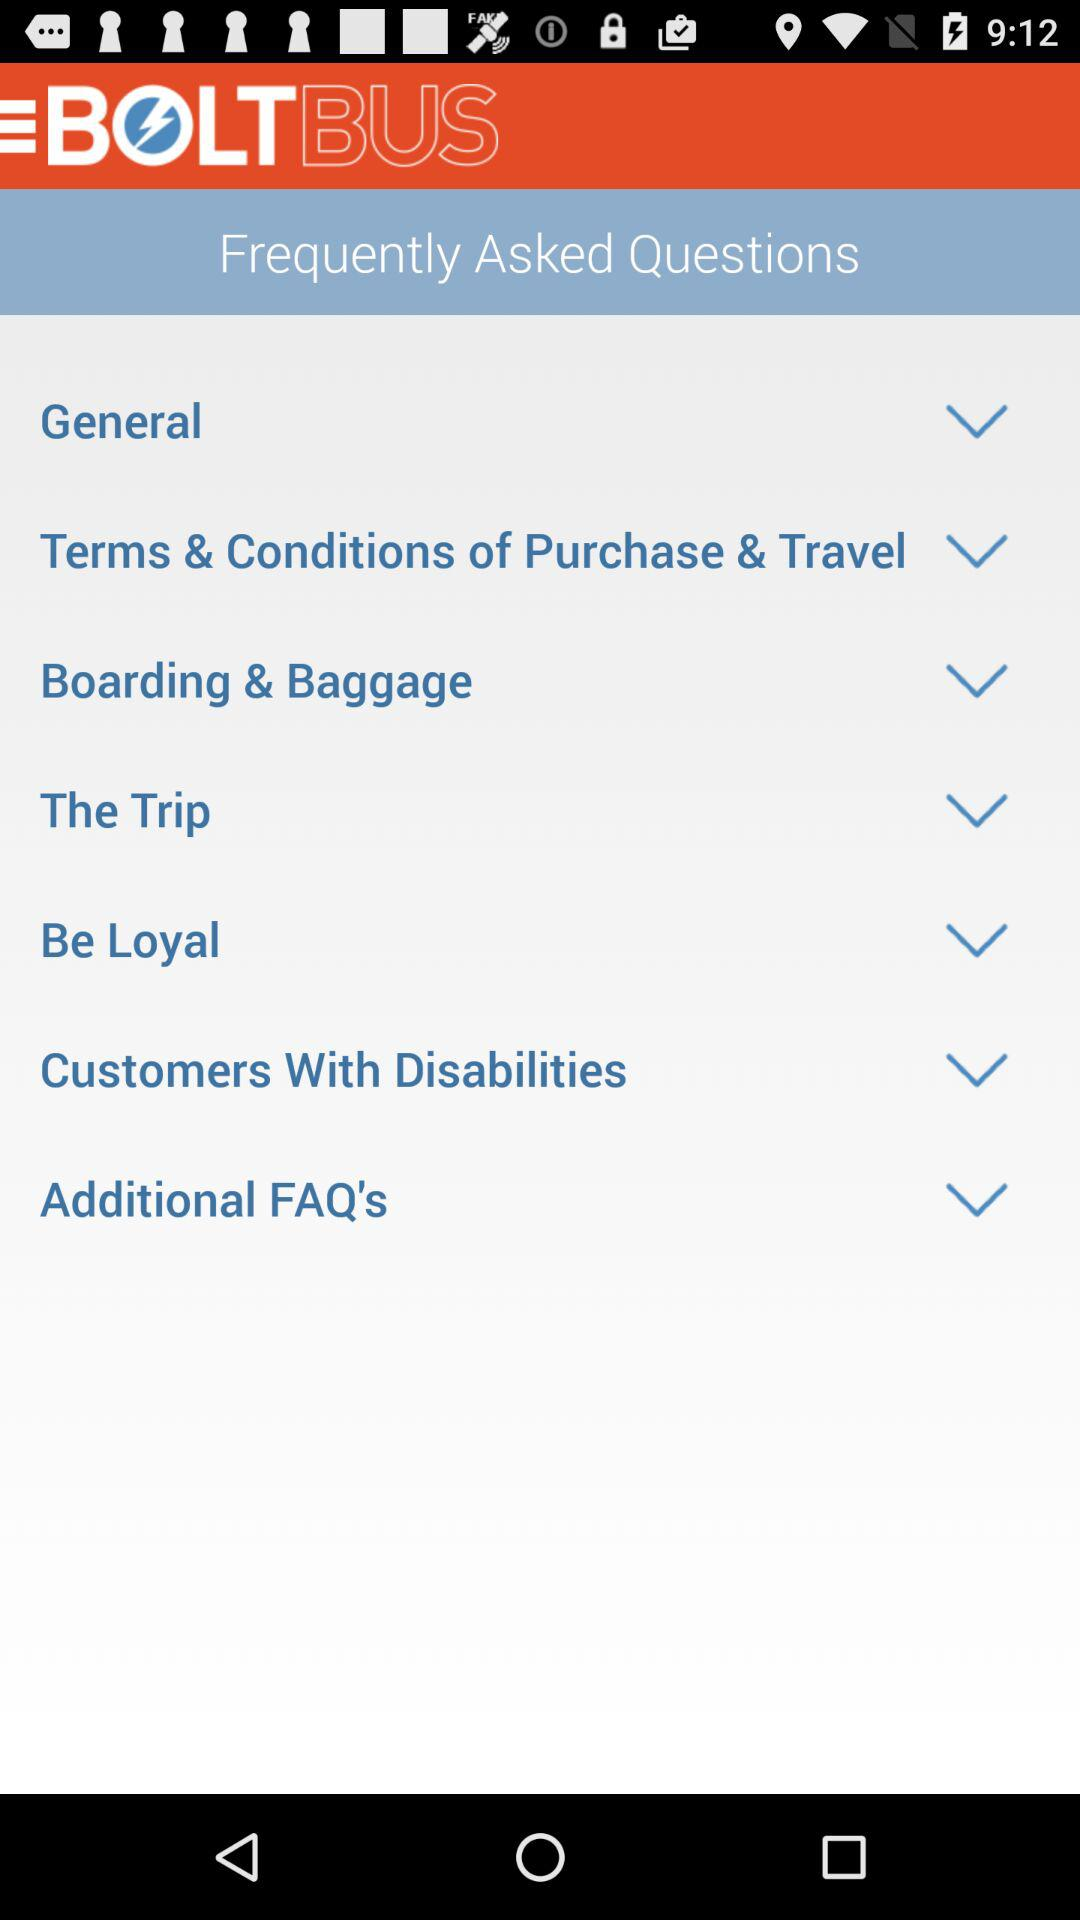What is the name of the application? The name of the application is "BOLTBUS". 